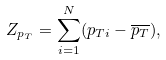Convert formula to latex. <formula><loc_0><loc_0><loc_500><loc_500>Z _ { p _ { T } } = \sum _ { i = 1 } ^ { N } ( p _ { T i } - \overline { p _ { T } } ) ,</formula> 